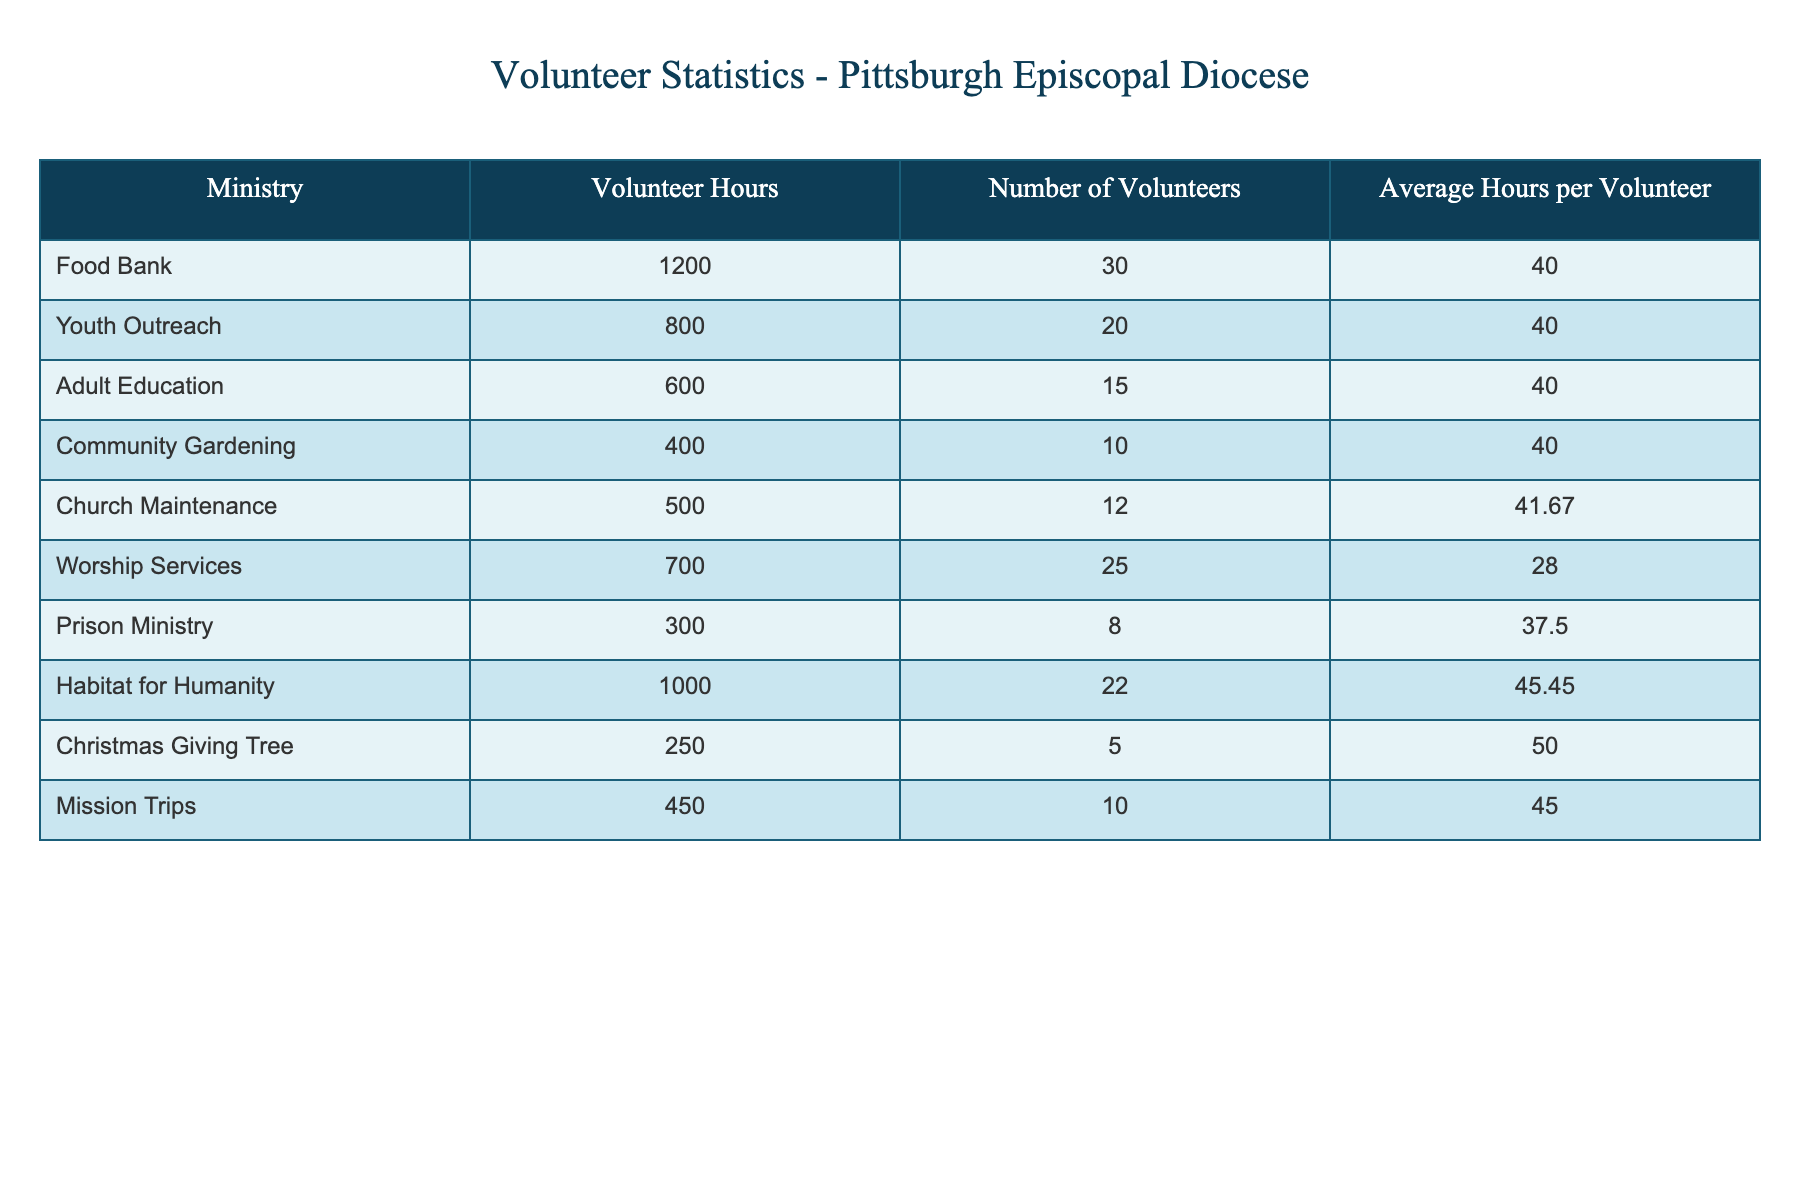What ministry logged the highest volunteer hours? By examining the "Volunteer Hours" column, the ministry with the highest logged hours is "Food Bank" with 1200 hours.
Answer: Food Bank What is the average number of volunteers across all ministries? To find the average number of volunteers, sum the "Number of Volunteers" for all ministries (30 + 20 + 15 + 10 + 12 + 25 + 8 + 22 + 5 + 10 =  252) and then divide by the number of ministries (10), resulting in an average of 252 / 10 = 25.2.
Answer: 25.2 Is the average volunteer hours per volunteer the same for all ministries? Checking the "Average Hours per Volunteer" column reveals that all ministries have an average of 40 hours per volunteer, except for Worship Services (28), Christmas Giving Tree (50), and Church Maintenance (41.67). Thus, the averages differ.
Answer: No Which ministry had the lowest volunteer hours and how many hours were logged? The table shows that "Prison Ministry" logged the lowest volunteer hours with only 300 hours.
Answer: Prison Ministry, 300 hours What is the total volunteer hours contributed by ministries related to community service (Food Bank, Youth Outreach, and Habitat for Humanity)? To find total community service hours, sum the hours from each ministry: Food Bank (1200) + Youth Outreach (800) + Habitat for Humanity (1000) = 3000 hours.
Answer: 3000 hours What is the difference in average hours per volunteer between the Ministry with the most and least average hours per volunteer? The ministry "Christmas Giving Tree" has an average of 50 hours per volunteer, whereas "Worship Services" has 28 hours. Therefore, the difference is 50 - 28 = 22 hours.
Answer: 22 hours How many ministries logged more than 500 volunteer hours? By checking the "Volunteer Hours" column, we find that the ministries that logged more than 500 hours are Food Bank (1200), Habitat for Humanity (1000), Youth Outreach (800), and Worship Services (700). This gives a total of 4 ministries.
Answer: 4 ministries Which ministry's average hours per volunteer is above 40? By reviewing the "Average Hours per Volunteer" column, only "Christmas Giving Tree" (50 hours) has an average above 40 hours. Thus, it is the only ministry that satisfies this condition.
Answer: Christmas Giving Tree 